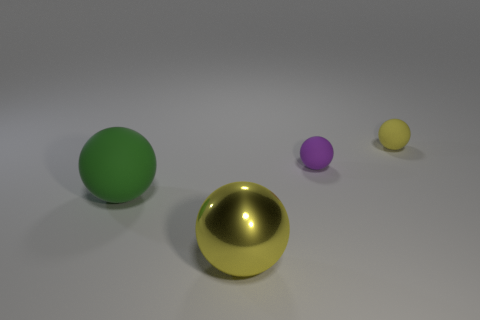There is a yellow rubber thing; is it the same size as the purple matte sphere that is behind the metallic ball?
Offer a very short reply. Yes. There is a yellow thing that is on the right side of the yellow sphere in front of the green sphere; how many things are to the left of it?
Your response must be concise. 3. How many yellow metal objects are behind the metallic ball?
Keep it short and to the point. 0. What is the color of the object to the right of the tiny object in front of the tiny yellow object?
Offer a very short reply. Yellow. How many other things are there of the same material as the green thing?
Offer a very short reply. 2. Are there an equal number of small yellow matte balls that are to the left of the yellow rubber object and blue matte spheres?
Keep it short and to the point. Yes. What is the material of the yellow object on the left side of the yellow sphere behind the yellow ball left of the tiny yellow rubber thing?
Your answer should be compact. Metal. The object in front of the green sphere is what color?
Your answer should be compact. Yellow. Is there anything else that is the same shape as the tiny yellow thing?
Give a very brief answer. Yes. What size is the yellow thing that is behind the yellow object in front of the tiny yellow rubber thing?
Give a very brief answer. Small. 